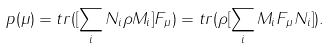Convert formula to latex. <formula><loc_0><loc_0><loc_500><loc_500>p ( \mu ) = t r ( [ \sum _ { i } N _ { i } \rho M _ { i } ] F _ { \mu } ) = t r ( \rho [ \sum _ { i } M _ { i } F _ { \mu } N _ { i } ] ) .</formula> 